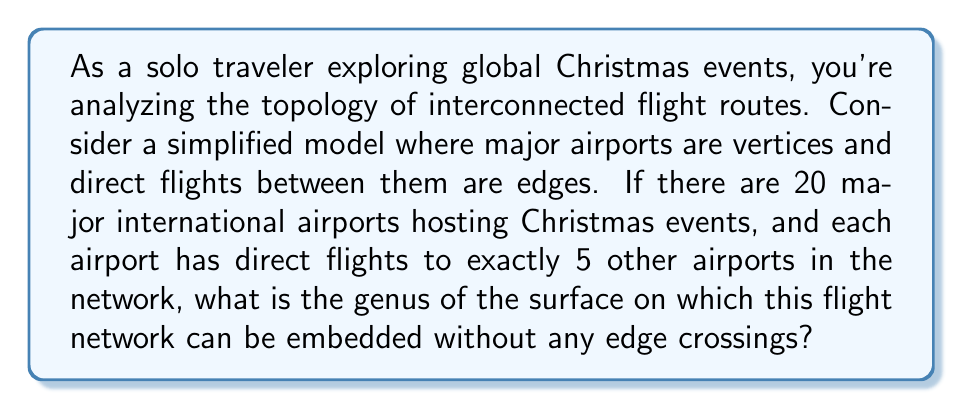Help me with this question. To solve this problem, we'll use the Euler characteristic and the concept of graph embedding on surfaces:

1) First, let's count the number of vertices (V), edges (E), and faces (F) in our graph:
   - Vertices (V): We have 20 airports, so V = 20
   - Edges (E): Each airport connects to 5 others, but this counts each edge twice, so E = (20 * 5) / 2 = 50
   - Faces (F): We need to calculate this using Euler's formula

2) The Euler characteristic (χ) for a surface with genus g is given by:
   $$ \chi = 2 - 2g $$

3) The Euler characteristic is also equal to V - E + F:
   $$ \chi = V - E + F $$

4) Equating these:
   $$ 2 - 2g = V - E + F $$

5) Rearranging to solve for F:
   $$ F = 2 - 2g - V + E $$

6) We want the minimum genus that allows embedding without crossings. The minimum genus occurs when F is maximum, which happens when each face is a triangle (any larger face could be divided into triangles).

7) In a triangle, each edge is shared by two faces. The number of triangles is:
   $$ F = \frac{2E}{3} $$

8) Substituting this into our equation from step 5:
   $$ \frac{2E}{3} = 2 - 2g - V + E $$

9) Substituting our known values (V = 20, E = 50):
   $$ \frac{2(50)}{3} = 2 - 2g - 20 + 50 $$

10) Simplifying:
    $$ \frac{100}{3} = 32 - 2g $$

11) Solving for g:
    $$ 2g = 32 - \frac{100}{3} = \frac{96}{3} - \frac{100}{3} = -\frac{4}{3} $$
    $$ g = -\frac{2}{3} $$

12) Since genus must be a non-negative integer, we round up to the nearest integer:
    $$ g = 0 $$

Therefore, this flight network can be embedded on a surface with genus 0, which is a sphere.
Answer: The genus of the surface on which the flight network can be embedded without edge crossings is 0 (a sphere). 